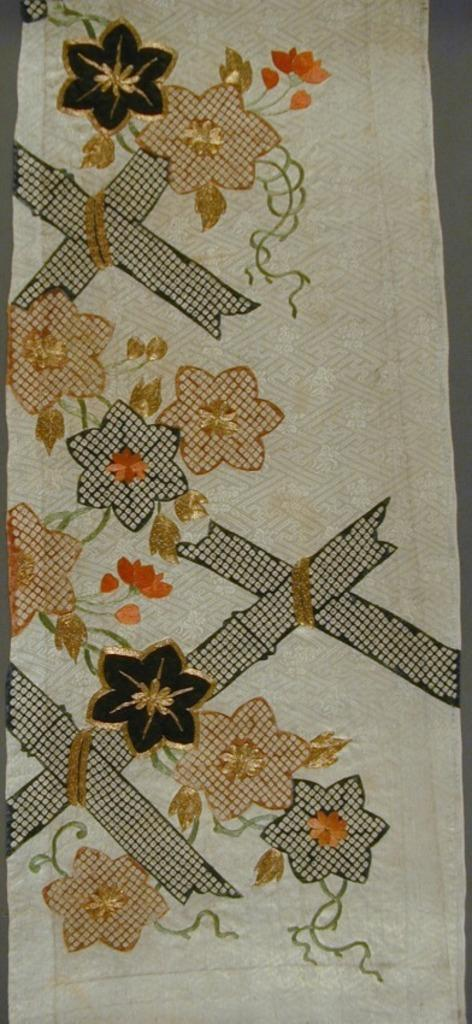What can be seen on the cloth in the image? There is a design on the cloth in the image. What type of mountain is visible through the window in the image? There is no mountain or window present in the image; it only features a cloth with a design. 